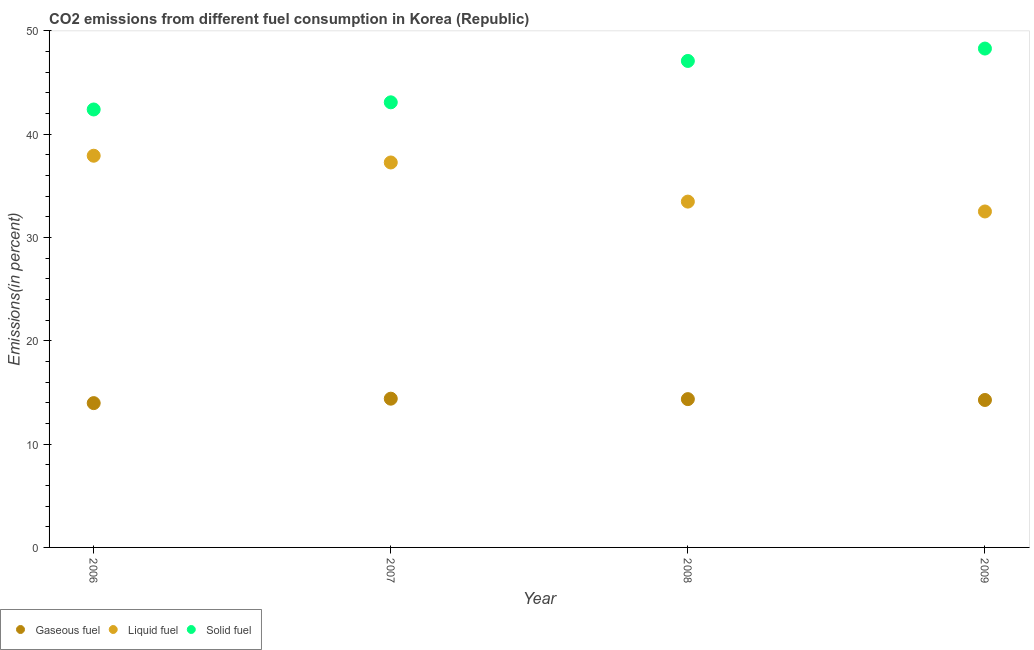How many different coloured dotlines are there?
Your answer should be compact. 3. Is the number of dotlines equal to the number of legend labels?
Your answer should be very brief. Yes. What is the percentage of liquid fuel emission in 2006?
Offer a terse response. 37.92. Across all years, what is the maximum percentage of liquid fuel emission?
Offer a terse response. 37.92. Across all years, what is the minimum percentage of gaseous fuel emission?
Make the answer very short. 13.97. In which year was the percentage of solid fuel emission maximum?
Give a very brief answer. 2009. What is the total percentage of gaseous fuel emission in the graph?
Provide a short and direct response. 57. What is the difference between the percentage of solid fuel emission in 2007 and that in 2009?
Ensure brevity in your answer.  -5.2. What is the difference between the percentage of liquid fuel emission in 2009 and the percentage of solid fuel emission in 2008?
Your answer should be very brief. -14.57. What is the average percentage of solid fuel emission per year?
Offer a terse response. 45.22. In the year 2009, what is the difference between the percentage of solid fuel emission and percentage of gaseous fuel emission?
Offer a very short reply. 34.02. What is the ratio of the percentage of solid fuel emission in 2006 to that in 2009?
Give a very brief answer. 0.88. Is the percentage of solid fuel emission in 2006 less than that in 2007?
Give a very brief answer. Yes. Is the difference between the percentage of gaseous fuel emission in 2006 and 2007 greater than the difference between the percentage of solid fuel emission in 2006 and 2007?
Your response must be concise. Yes. What is the difference between the highest and the second highest percentage of gaseous fuel emission?
Give a very brief answer. 0.04. What is the difference between the highest and the lowest percentage of gaseous fuel emission?
Your answer should be compact. 0.43. Is the sum of the percentage of solid fuel emission in 2007 and 2009 greater than the maximum percentage of gaseous fuel emission across all years?
Ensure brevity in your answer.  Yes. Is it the case that in every year, the sum of the percentage of gaseous fuel emission and percentage of liquid fuel emission is greater than the percentage of solid fuel emission?
Ensure brevity in your answer.  No. Does the percentage of solid fuel emission monotonically increase over the years?
Your answer should be very brief. Yes. Is the percentage of liquid fuel emission strictly greater than the percentage of gaseous fuel emission over the years?
Make the answer very short. Yes. Is the percentage of liquid fuel emission strictly less than the percentage of gaseous fuel emission over the years?
Make the answer very short. No. How many years are there in the graph?
Ensure brevity in your answer.  4. What is the difference between two consecutive major ticks on the Y-axis?
Give a very brief answer. 10. Are the values on the major ticks of Y-axis written in scientific E-notation?
Your answer should be very brief. No. How are the legend labels stacked?
Keep it short and to the point. Horizontal. What is the title of the graph?
Your answer should be compact. CO2 emissions from different fuel consumption in Korea (Republic). What is the label or title of the Y-axis?
Ensure brevity in your answer.  Emissions(in percent). What is the Emissions(in percent) in Gaseous fuel in 2006?
Your answer should be very brief. 13.97. What is the Emissions(in percent) of Liquid fuel in 2006?
Provide a succinct answer. 37.92. What is the Emissions(in percent) in Solid fuel in 2006?
Give a very brief answer. 42.39. What is the Emissions(in percent) of Gaseous fuel in 2007?
Your answer should be compact. 14.4. What is the Emissions(in percent) of Liquid fuel in 2007?
Keep it short and to the point. 37.26. What is the Emissions(in percent) in Solid fuel in 2007?
Your response must be concise. 43.09. What is the Emissions(in percent) of Gaseous fuel in 2008?
Make the answer very short. 14.36. What is the Emissions(in percent) in Liquid fuel in 2008?
Offer a terse response. 33.48. What is the Emissions(in percent) in Solid fuel in 2008?
Offer a very short reply. 47.09. What is the Emissions(in percent) in Gaseous fuel in 2009?
Offer a terse response. 14.27. What is the Emissions(in percent) of Liquid fuel in 2009?
Your response must be concise. 32.52. What is the Emissions(in percent) of Solid fuel in 2009?
Your answer should be compact. 48.29. Across all years, what is the maximum Emissions(in percent) of Gaseous fuel?
Your answer should be compact. 14.4. Across all years, what is the maximum Emissions(in percent) in Liquid fuel?
Your answer should be very brief. 37.92. Across all years, what is the maximum Emissions(in percent) of Solid fuel?
Your response must be concise. 48.29. Across all years, what is the minimum Emissions(in percent) of Gaseous fuel?
Give a very brief answer. 13.97. Across all years, what is the minimum Emissions(in percent) of Liquid fuel?
Your answer should be very brief. 32.52. Across all years, what is the minimum Emissions(in percent) of Solid fuel?
Provide a short and direct response. 42.39. What is the total Emissions(in percent) in Gaseous fuel in the graph?
Keep it short and to the point. 57. What is the total Emissions(in percent) in Liquid fuel in the graph?
Your answer should be very brief. 141.18. What is the total Emissions(in percent) in Solid fuel in the graph?
Offer a terse response. 180.87. What is the difference between the Emissions(in percent) in Gaseous fuel in 2006 and that in 2007?
Your answer should be compact. -0.43. What is the difference between the Emissions(in percent) of Liquid fuel in 2006 and that in 2007?
Make the answer very short. 0.65. What is the difference between the Emissions(in percent) in Solid fuel in 2006 and that in 2007?
Your response must be concise. -0.69. What is the difference between the Emissions(in percent) in Gaseous fuel in 2006 and that in 2008?
Your answer should be compact. -0.39. What is the difference between the Emissions(in percent) in Liquid fuel in 2006 and that in 2008?
Your response must be concise. 4.44. What is the difference between the Emissions(in percent) of Solid fuel in 2006 and that in 2008?
Ensure brevity in your answer.  -4.7. What is the difference between the Emissions(in percent) in Gaseous fuel in 2006 and that in 2009?
Keep it short and to the point. -0.3. What is the difference between the Emissions(in percent) of Liquid fuel in 2006 and that in 2009?
Your response must be concise. 5.4. What is the difference between the Emissions(in percent) in Solid fuel in 2006 and that in 2009?
Your response must be concise. -5.9. What is the difference between the Emissions(in percent) of Gaseous fuel in 2007 and that in 2008?
Provide a short and direct response. 0.04. What is the difference between the Emissions(in percent) in Liquid fuel in 2007 and that in 2008?
Your answer should be very brief. 3.79. What is the difference between the Emissions(in percent) of Solid fuel in 2007 and that in 2008?
Offer a terse response. -4.01. What is the difference between the Emissions(in percent) in Gaseous fuel in 2007 and that in 2009?
Keep it short and to the point. 0.13. What is the difference between the Emissions(in percent) in Liquid fuel in 2007 and that in 2009?
Provide a succinct answer. 4.74. What is the difference between the Emissions(in percent) in Solid fuel in 2007 and that in 2009?
Keep it short and to the point. -5.2. What is the difference between the Emissions(in percent) of Gaseous fuel in 2008 and that in 2009?
Provide a succinct answer. 0.08. What is the difference between the Emissions(in percent) in Liquid fuel in 2008 and that in 2009?
Make the answer very short. 0.95. What is the difference between the Emissions(in percent) in Solid fuel in 2008 and that in 2009?
Ensure brevity in your answer.  -1.2. What is the difference between the Emissions(in percent) in Gaseous fuel in 2006 and the Emissions(in percent) in Liquid fuel in 2007?
Make the answer very short. -23.29. What is the difference between the Emissions(in percent) in Gaseous fuel in 2006 and the Emissions(in percent) in Solid fuel in 2007?
Your answer should be very brief. -29.12. What is the difference between the Emissions(in percent) in Liquid fuel in 2006 and the Emissions(in percent) in Solid fuel in 2007?
Give a very brief answer. -5.17. What is the difference between the Emissions(in percent) in Gaseous fuel in 2006 and the Emissions(in percent) in Liquid fuel in 2008?
Your answer should be compact. -19.51. What is the difference between the Emissions(in percent) in Gaseous fuel in 2006 and the Emissions(in percent) in Solid fuel in 2008?
Offer a terse response. -33.12. What is the difference between the Emissions(in percent) in Liquid fuel in 2006 and the Emissions(in percent) in Solid fuel in 2008?
Your answer should be very brief. -9.18. What is the difference between the Emissions(in percent) in Gaseous fuel in 2006 and the Emissions(in percent) in Liquid fuel in 2009?
Your answer should be very brief. -18.55. What is the difference between the Emissions(in percent) in Gaseous fuel in 2006 and the Emissions(in percent) in Solid fuel in 2009?
Your answer should be very brief. -34.32. What is the difference between the Emissions(in percent) of Liquid fuel in 2006 and the Emissions(in percent) of Solid fuel in 2009?
Make the answer very short. -10.38. What is the difference between the Emissions(in percent) of Gaseous fuel in 2007 and the Emissions(in percent) of Liquid fuel in 2008?
Your answer should be very brief. -19.08. What is the difference between the Emissions(in percent) in Gaseous fuel in 2007 and the Emissions(in percent) in Solid fuel in 2008?
Provide a succinct answer. -32.69. What is the difference between the Emissions(in percent) in Liquid fuel in 2007 and the Emissions(in percent) in Solid fuel in 2008?
Keep it short and to the point. -9.83. What is the difference between the Emissions(in percent) in Gaseous fuel in 2007 and the Emissions(in percent) in Liquid fuel in 2009?
Ensure brevity in your answer.  -18.12. What is the difference between the Emissions(in percent) in Gaseous fuel in 2007 and the Emissions(in percent) in Solid fuel in 2009?
Offer a terse response. -33.89. What is the difference between the Emissions(in percent) of Liquid fuel in 2007 and the Emissions(in percent) of Solid fuel in 2009?
Make the answer very short. -11.03. What is the difference between the Emissions(in percent) in Gaseous fuel in 2008 and the Emissions(in percent) in Liquid fuel in 2009?
Your response must be concise. -18.16. What is the difference between the Emissions(in percent) of Gaseous fuel in 2008 and the Emissions(in percent) of Solid fuel in 2009?
Offer a terse response. -33.94. What is the difference between the Emissions(in percent) in Liquid fuel in 2008 and the Emissions(in percent) in Solid fuel in 2009?
Make the answer very short. -14.82. What is the average Emissions(in percent) of Gaseous fuel per year?
Ensure brevity in your answer.  14.25. What is the average Emissions(in percent) in Liquid fuel per year?
Provide a short and direct response. 35.29. What is the average Emissions(in percent) of Solid fuel per year?
Provide a succinct answer. 45.22. In the year 2006, what is the difference between the Emissions(in percent) of Gaseous fuel and Emissions(in percent) of Liquid fuel?
Offer a terse response. -23.95. In the year 2006, what is the difference between the Emissions(in percent) of Gaseous fuel and Emissions(in percent) of Solid fuel?
Keep it short and to the point. -28.42. In the year 2006, what is the difference between the Emissions(in percent) of Liquid fuel and Emissions(in percent) of Solid fuel?
Keep it short and to the point. -4.48. In the year 2007, what is the difference between the Emissions(in percent) in Gaseous fuel and Emissions(in percent) in Liquid fuel?
Provide a short and direct response. -22.87. In the year 2007, what is the difference between the Emissions(in percent) of Gaseous fuel and Emissions(in percent) of Solid fuel?
Offer a very short reply. -28.69. In the year 2007, what is the difference between the Emissions(in percent) in Liquid fuel and Emissions(in percent) in Solid fuel?
Give a very brief answer. -5.82. In the year 2008, what is the difference between the Emissions(in percent) in Gaseous fuel and Emissions(in percent) in Liquid fuel?
Your response must be concise. -19.12. In the year 2008, what is the difference between the Emissions(in percent) of Gaseous fuel and Emissions(in percent) of Solid fuel?
Offer a very short reply. -32.74. In the year 2008, what is the difference between the Emissions(in percent) in Liquid fuel and Emissions(in percent) in Solid fuel?
Provide a short and direct response. -13.62. In the year 2009, what is the difference between the Emissions(in percent) in Gaseous fuel and Emissions(in percent) in Liquid fuel?
Keep it short and to the point. -18.25. In the year 2009, what is the difference between the Emissions(in percent) of Gaseous fuel and Emissions(in percent) of Solid fuel?
Give a very brief answer. -34.02. In the year 2009, what is the difference between the Emissions(in percent) in Liquid fuel and Emissions(in percent) in Solid fuel?
Keep it short and to the point. -15.77. What is the ratio of the Emissions(in percent) of Gaseous fuel in 2006 to that in 2007?
Your answer should be very brief. 0.97. What is the ratio of the Emissions(in percent) of Liquid fuel in 2006 to that in 2007?
Give a very brief answer. 1.02. What is the ratio of the Emissions(in percent) in Solid fuel in 2006 to that in 2007?
Ensure brevity in your answer.  0.98. What is the ratio of the Emissions(in percent) of Gaseous fuel in 2006 to that in 2008?
Your response must be concise. 0.97. What is the ratio of the Emissions(in percent) of Liquid fuel in 2006 to that in 2008?
Keep it short and to the point. 1.13. What is the ratio of the Emissions(in percent) in Solid fuel in 2006 to that in 2008?
Keep it short and to the point. 0.9. What is the ratio of the Emissions(in percent) in Gaseous fuel in 2006 to that in 2009?
Offer a terse response. 0.98. What is the ratio of the Emissions(in percent) of Liquid fuel in 2006 to that in 2009?
Give a very brief answer. 1.17. What is the ratio of the Emissions(in percent) of Solid fuel in 2006 to that in 2009?
Your response must be concise. 0.88. What is the ratio of the Emissions(in percent) of Liquid fuel in 2007 to that in 2008?
Offer a terse response. 1.11. What is the ratio of the Emissions(in percent) of Solid fuel in 2007 to that in 2008?
Your answer should be compact. 0.91. What is the ratio of the Emissions(in percent) in Gaseous fuel in 2007 to that in 2009?
Make the answer very short. 1.01. What is the ratio of the Emissions(in percent) in Liquid fuel in 2007 to that in 2009?
Your answer should be compact. 1.15. What is the ratio of the Emissions(in percent) of Solid fuel in 2007 to that in 2009?
Give a very brief answer. 0.89. What is the ratio of the Emissions(in percent) in Gaseous fuel in 2008 to that in 2009?
Give a very brief answer. 1.01. What is the ratio of the Emissions(in percent) in Liquid fuel in 2008 to that in 2009?
Offer a terse response. 1.03. What is the ratio of the Emissions(in percent) in Solid fuel in 2008 to that in 2009?
Your answer should be compact. 0.98. What is the difference between the highest and the second highest Emissions(in percent) of Gaseous fuel?
Offer a terse response. 0.04. What is the difference between the highest and the second highest Emissions(in percent) of Liquid fuel?
Offer a very short reply. 0.65. What is the difference between the highest and the second highest Emissions(in percent) of Solid fuel?
Your response must be concise. 1.2. What is the difference between the highest and the lowest Emissions(in percent) in Gaseous fuel?
Your response must be concise. 0.43. What is the difference between the highest and the lowest Emissions(in percent) in Liquid fuel?
Your answer should be compact. 5.4. What is the difference between the highest and the lowest Emissions(in percent) of Solid fuel?
Provide a succinct answer. 5.9. 